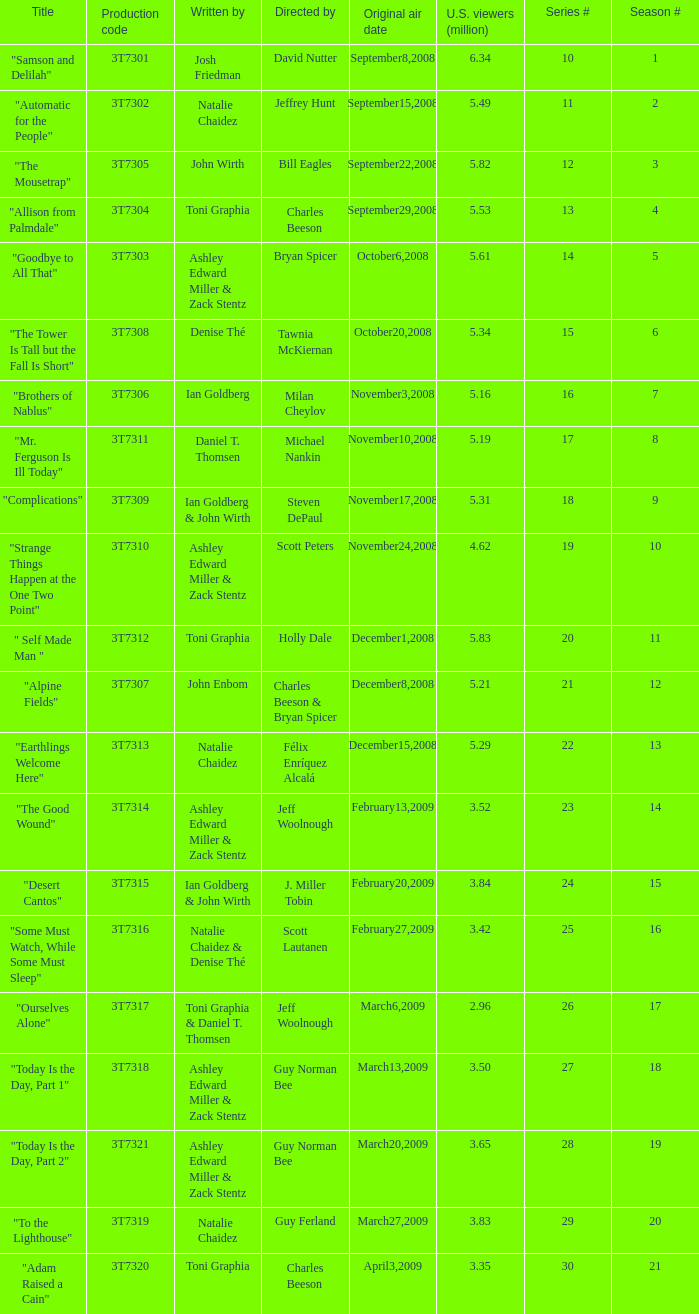Which episode number was directed by Bill Eagles? 12.0. 